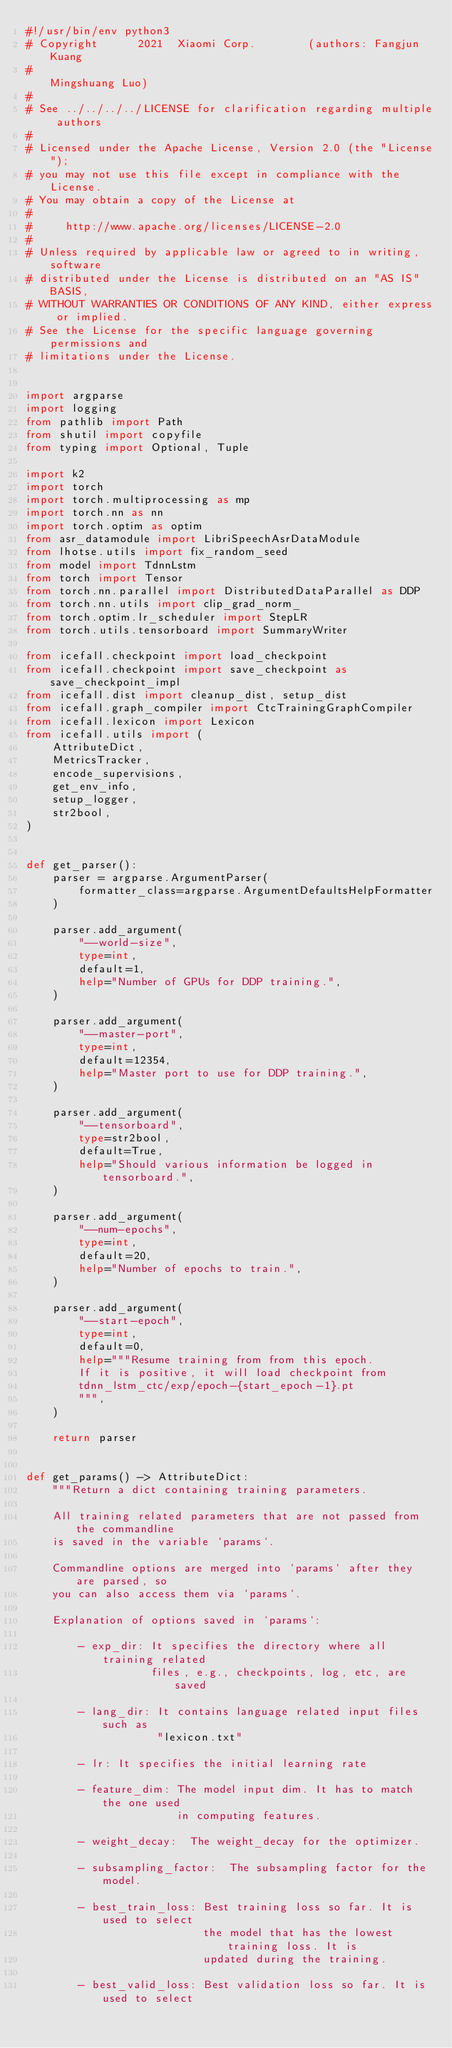Convert code to text. <code><loc_0><loc_0><loc_500><loc_500><_Python_>#!/usr/bin/env python3
# Copyright      2021  Xiaomi Corp.        (authors: Fangjun Kuang
#                                                    Mingshuang Luo)
#
# See ../../../../LICENSE for clarification regarding multiple authors
#
# Licensed under the Apache License, Version 2.0 (the "License");
# you may not use this file except in compliance with the License.
# You may obtain a copy of the License at
#
#     http://www.apache.org/licenses/LICENSE-2.0
#
# Unless required by applicable law or agreed to in writing, software
# distributed under the License is distributed on an "AS IS" BASIS,
# WITHOUT WARRANTIES OR CONDITIONS OF ANY KIND, either express or implied.
# See the License for the specific language governing permissions and
# limitations under the License.


import argparse
import logging
from pathlib import Path
from shutil import copyfile
from typing import Optional, Tuple

import k2
import torch
import torch.multiprocessing as mp
import torch.nn as nn
import torch.optim as optim
from asr_datamodule import LibriSpeechAsrDataModule
from lhotse.utils import fix_random_seed
from model import TdnnLstm
from torch import Tensor
from torch.nn.parallel import DistributedDataParallel as DDP
from torch.nn.utils import clip_grad_norm_
from torch.optim.lr_scheduler import StepLR
from torch.utils.tensorboard import SummaryWriter

from icefall.checkpoint import load_checkpoint
from icefall.checkpoint import save_checkpoint as save_checkpoint_impl
from icefall.dist import cleanup_dist, setup_dist
from icefall.graph_compiler import CtcTrainingGraphCompiler
from icefall.lexicon import Lexicon
from icefall.utils import (
    AttributeDict,
    MetricsTracker,
    encode_supervisions,
    get_env_info,
    setup_logger,
    str2bool,
)


def get_parser():
    parser = argparse.ArgumentParser(
        formatter_class=argparse.ArgumentDefaultsHelpFormatter
    )

    parser.add_argument(
        "--world-size",
        type=int,
        default=1,
        help="Number of GPUs for DDP training.",
    )

    parser.add_argument(
        "--master-port",
        type=int,
        default=12354,
        help="Master port to use for DDP training.",
    )

    parser.add_argument(
        "--tensorboard",
        type=str2bool,
        default=True,
        help="Should various information be logged in tensorboard.",
    )

    parser.add_argument(
        "--num-epochs",
        type=int,
        default=20,
        help="Number of epochs to train.",
    )

    parser.add_argument(
        "--start-epoch",
        type=int,
        default=0,
        help="""Resume training from from this epoch.
        If it is positive, it will load checkpoint from
        tdnn_lstm_ctc/exp/epoch-{start_epoch-1}.pt
        """,
    )

    return parser


def get_params() -> AttributeDict:
    """Return a dict containing training parameters.

    All training related parameters that are not passed from the commandline
    is saved in the variable `params`.

    Commandline options are merged into `params` after they are parsed, so
    you can also access them via `params`.

    Explanation of options saved in `params`:

        - exp_dir: It specifies the directory where all training related
                   files, e.g., checkpoints, log, etc, are saved

        - lang_dir: It contains language related input files such as
                    "lexicon.txt"

        - lr: It specifies the initial learning rate

        - feature_dim: The model input dim. It has to match the one used
                       in computing features.

        - weight_decay:  The weight_decay for the optimizer.

        - subsampling_factor:  The subsampling factor for the model.

        - best_train_loss: Best training loss so far. It is used to select
                           the model that has the lowest training loss. It is
                           updated during the training.

        - best_valid_loss: Best validation loss so far. It is used to select</code> 